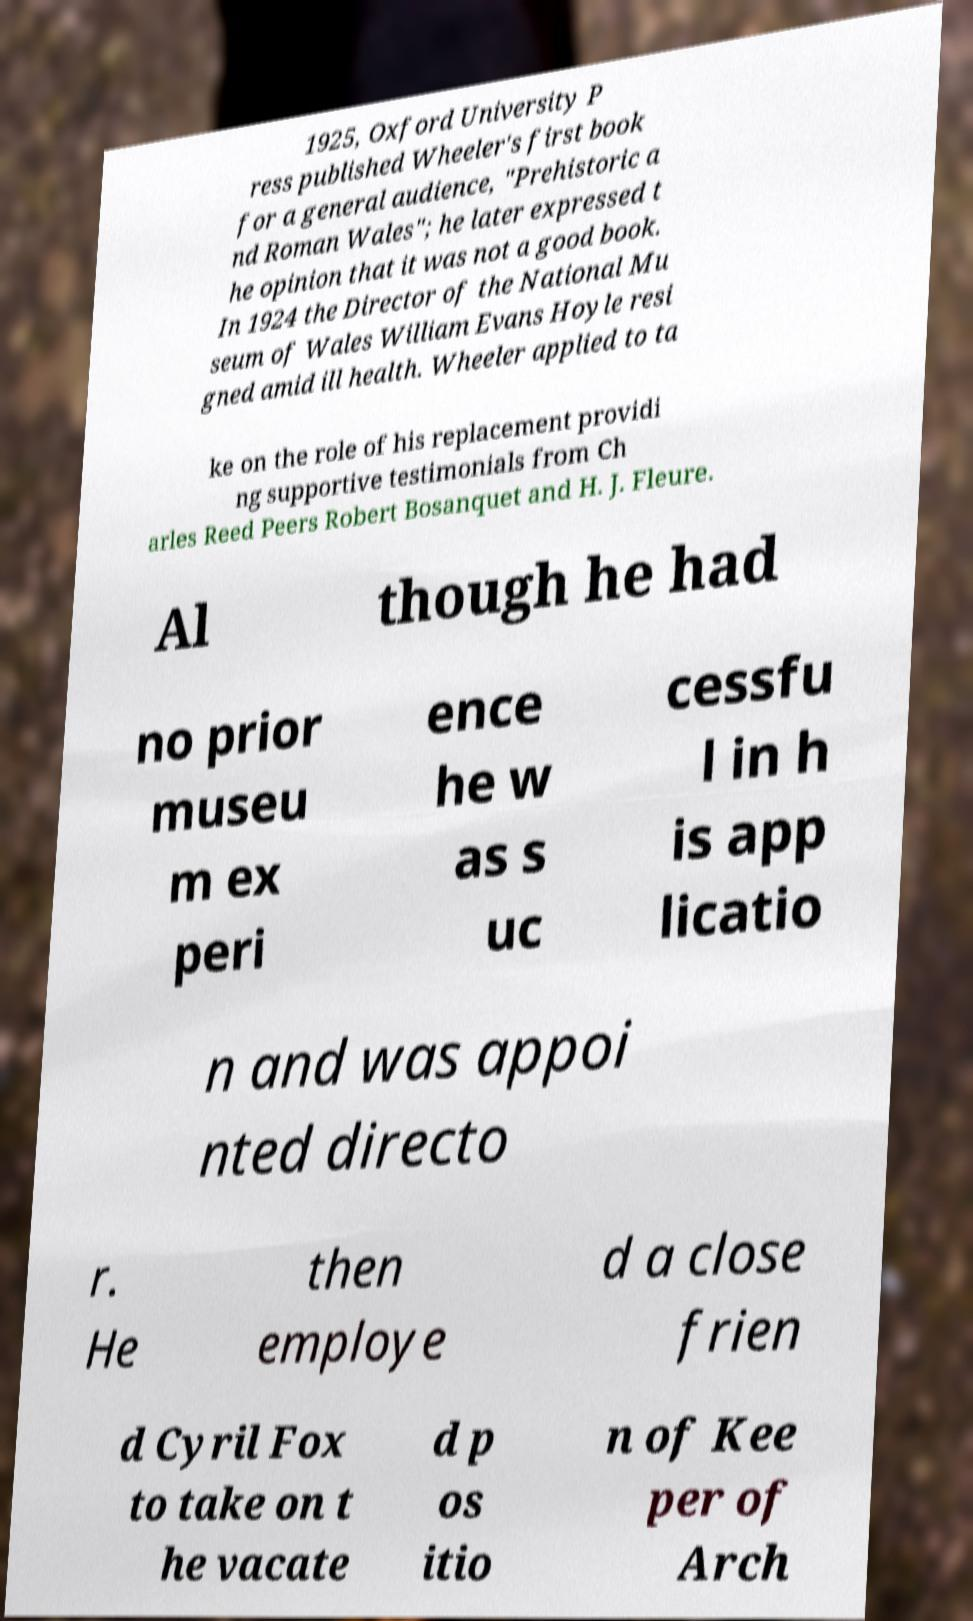Could you extract and type out the text from this image? 1925, Oxford University P ress published Wheeler's first book for a general audience, "Prehistoric a nd Roman Wales"; he later expressed t he opinion that it was not a good book. In 1924 the Director of the National Mu seum of Wales William Evans Hoyle resi gned amid ill health. Wheeler applied to ta ke on the role of his replacement providi ng supportive testimonials from Ch arles Reed Peers Robert Bosanquet and H. J. Fleure. Al though he had no prior museu m ex peri ence he w as s uc cessfu l in h is app licatio n and was appoi nted directo r. He then employe d a close frien d Cyril Fox to take on t he vacate d p os itio n of Kee per of Arch 